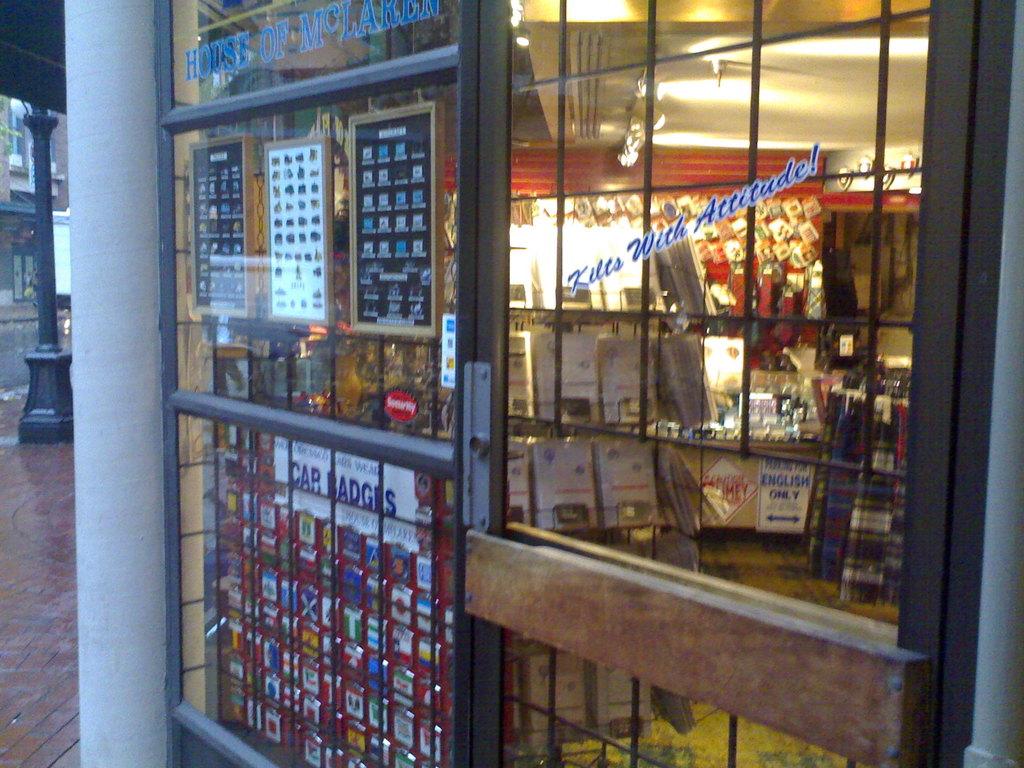What has attitude?
Give a very brief answer. Kilts. 